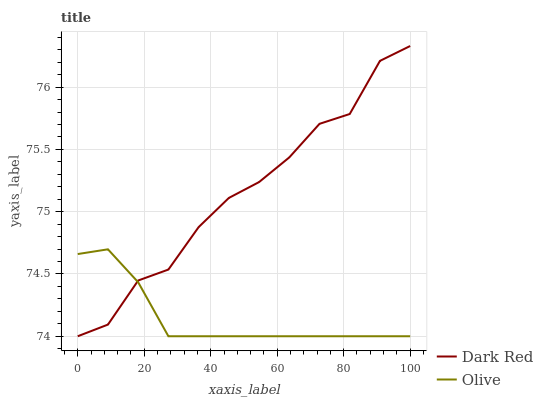Does Olive have the minimum area under the curve?
Answer yes or no. Yes. Does Dark Red have the maximum area under the curve?
Answer yes or no. Yes. Does Dark Red have the minimum area under the curve?
Answer yes or no. No. Is Olive the smoothest?
Answer yes or no. Yes. Is Dark Red the roughest?
Answer yes or no. Yes. Is Dark Red the smoothest?
Answer yes or no. No. Does Olive have the lowest value?
Answer yes or no. Yes. Does Dark Red have the highest value?
Answer yes or no. Yes. Does Dark Red intersect Olive?
Answer yes or no. Yes. Is Dark Red less than Olive?
Answer yes or no. No. Is Dark Red greater than Olive?
Answer yes or no. No. 